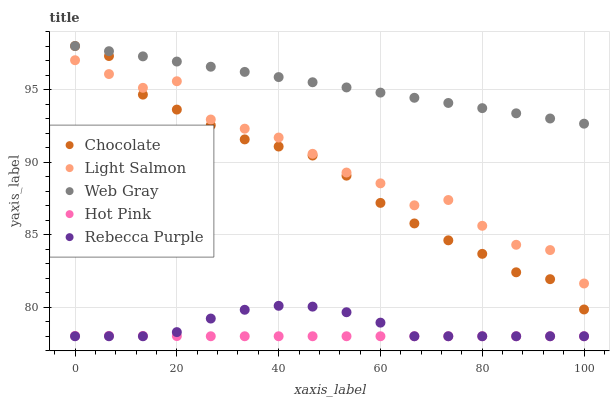Does Hot Pink have the minimum area under the curve?
Answer yes or no. Yes. Does Web Gray have the maximum area under the curve?
Answer yes or no. Yes. Does Web Gray have the minimum area under the curve?
Answer yes or no. No. Does Hot Pink have the maximum area under the curve?
Answer yes or no. No. Is Web Gray the smoothest?
Answer yes or no. Yes. Is Light Salmon the roughest?
Answer yes or no. Yes. Is Hot Pink the smoothest?
Answer yes or no. No. Is Hot Pink the roughest?
Answer yes or no. No. Does Hot Pink have the lowest value?
Answer yes or no. Yes. Does Web Gray have the lowest value?
Answer yes or no. No. Does Chocolate have the highest value?
Answer yes or no. Yes. Does Hot Pink have the highest value?
Answer yes or no. No. Is Light Salmon less than Web Gray?
Answer yes or no. Yes. Is Light Salmon greater than Rebecca Purple?
Answer yes or no. Yes. Does Chocolate intersect Light Salmon?
Answer yes or no. Yes. Is Chocolate less than Light Salmon?
Answer yes or no. No. Is Chocolate greater than Light Salmon?
Answer yes or no. No. Does Light Salmon intersect Web Gray?
Answer yes or no. No. 